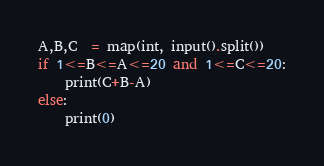Convert code to text. <code><loc_0><loc_0><loc_500><loc_500><_Python_>A,B,C  = map(int, input().split())
if 1<=B<=A<=20 and 1<=C<=20:
    print(C+B-A)
else:
    print(0)</code> 